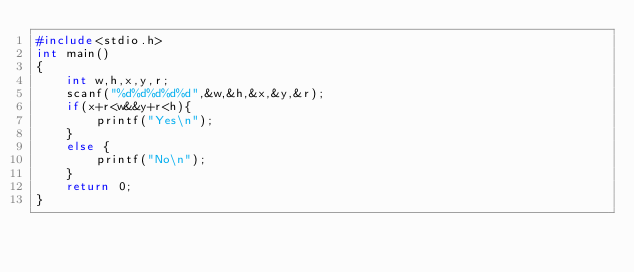Convert code to text. <code><loc_0><loc_0><loc_500><loc_500><_C_>#include<stdio.h>
int main()
{
	int w,h,x,y,r;
	scanf("%d%d%d%d%d",&w,&h,&x,&y,&r);
	if(x+r<w&&y+r<h){
		printf("Yes\n");
	}
	else {
		printf("No\n");
	}
	return 0;
}
</code> 